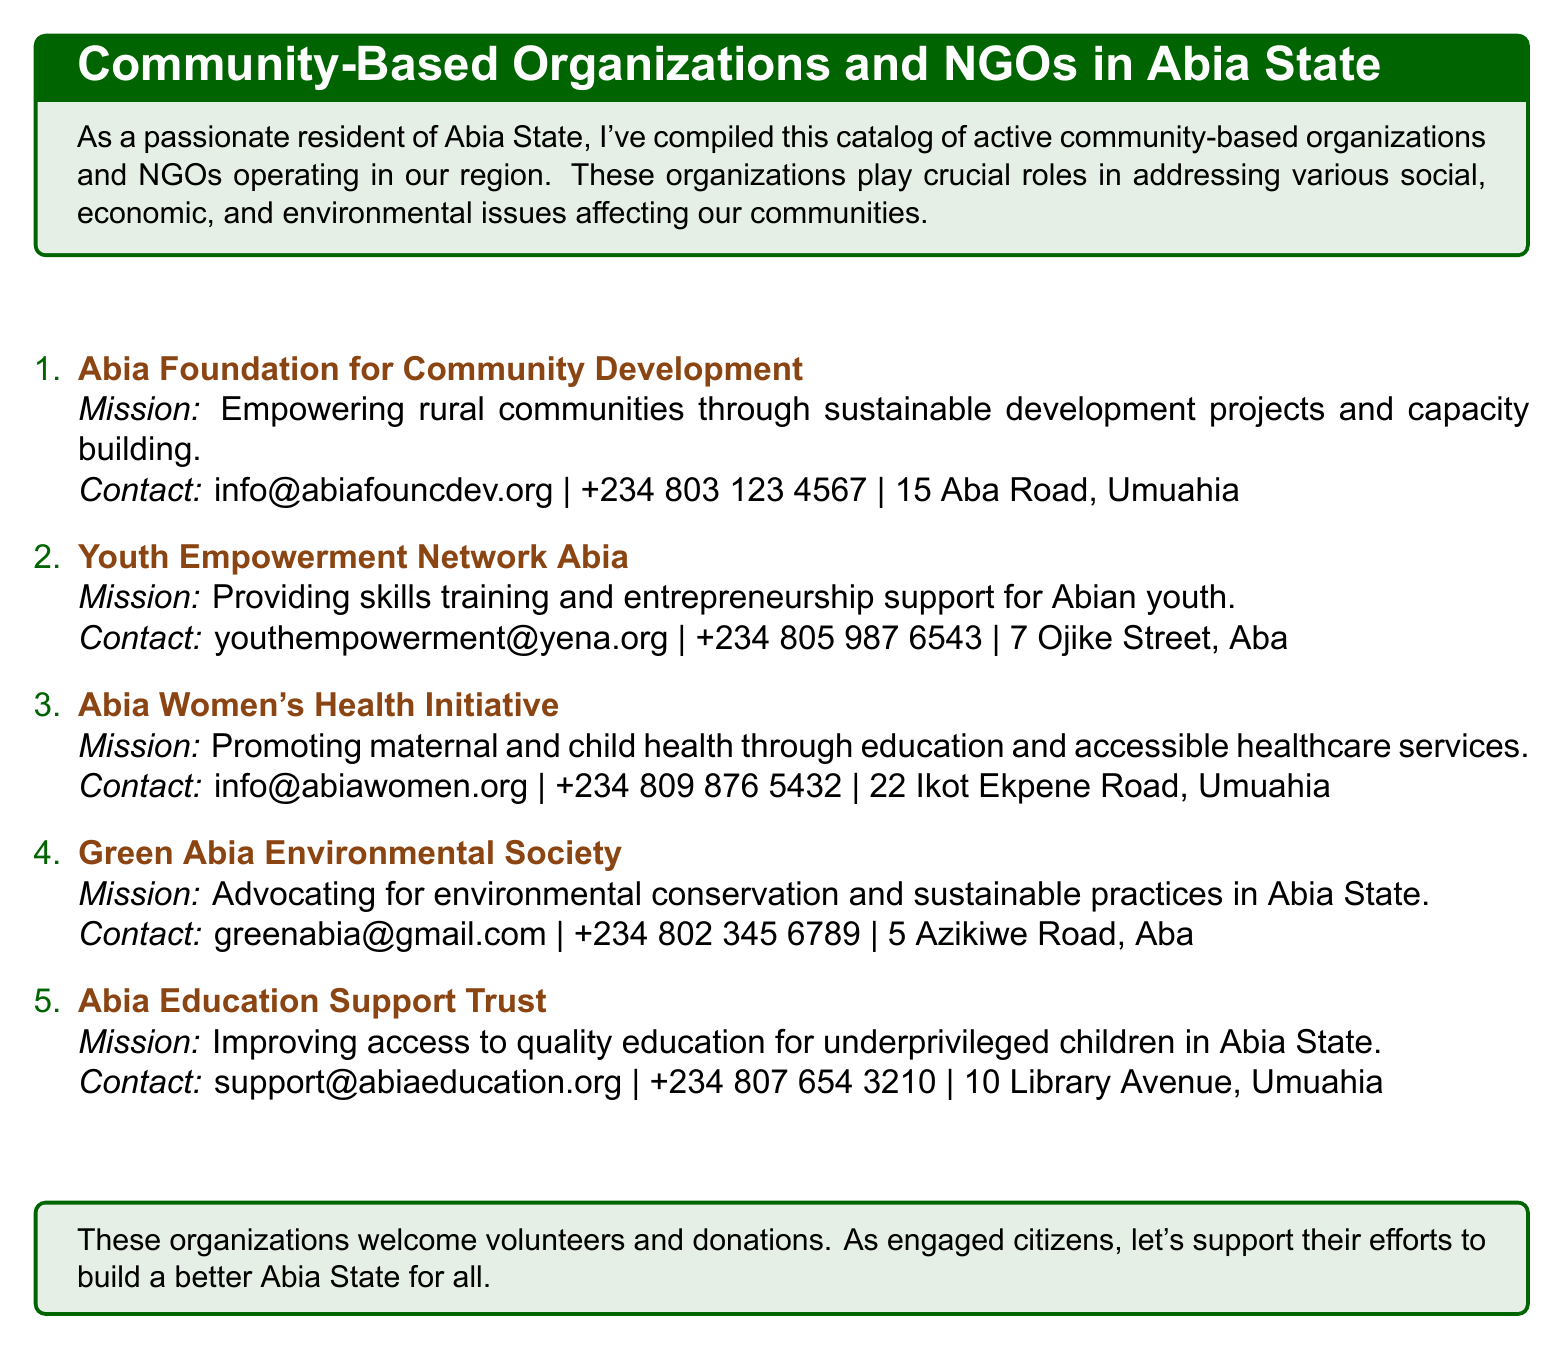What is the mission of the Abia Foundation for Community Development? The mission is to empower rural communities through sustainable development projects and capacity building.
Answer: Empowering rural communities through sustainable development projects and capacity building What contact number is associated with Youth Empowerment Network Abia? The document provides the contact number, which is +234 805 987 6543.
Answer: +234 805 987 6543 How many community organizations are listed in the document? The document lists five community organizations.
Answer: 5 What is the mission of the Abia Women's Health Initiative? The mission focuses on promoting maternal and child health through education and accessible healthcare services.
Answer: Promoting maternal and child health through education and accessible healthcare services What is the email contact of the Green Abia Environmental Society? The email is provided as greenabia@gmail.com.
Answer: greenabia@gmail.com Which organization aims to improve access to quality education? The document specifies the Abia Education Support Trust as the organization aiming to improve access to quality education for underprivileged children.
Answer: Abia Education Support Trust How many different locations are mentioned for the organizations? The document mentions four different locations: Umuahia (2), Aba (2).
Answer: 4 What type of support does Youth Empowerment Network Abia provide? The organization provides skills training and entrepreneurship support for youth.
Answer: Skills training and entrepreneurship support 